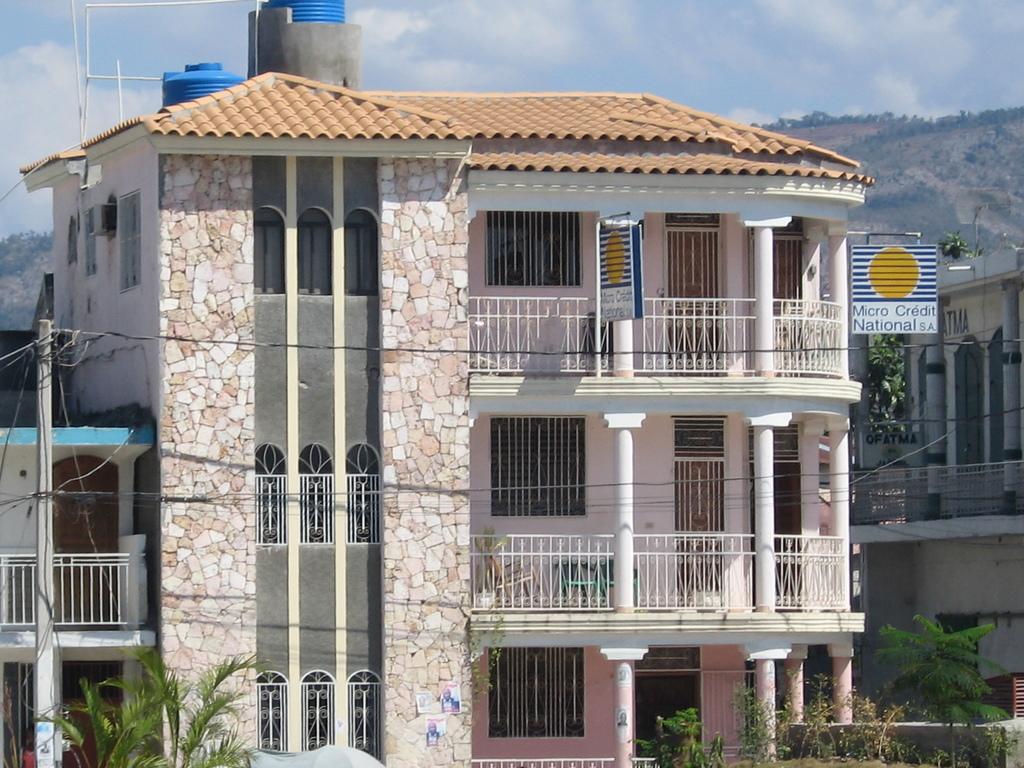How would you summarize this image in a sentence or two? It is a very big building, there are water tanks in blue color on it. At the bottom there are trees and at the top it is the blue color sky. 